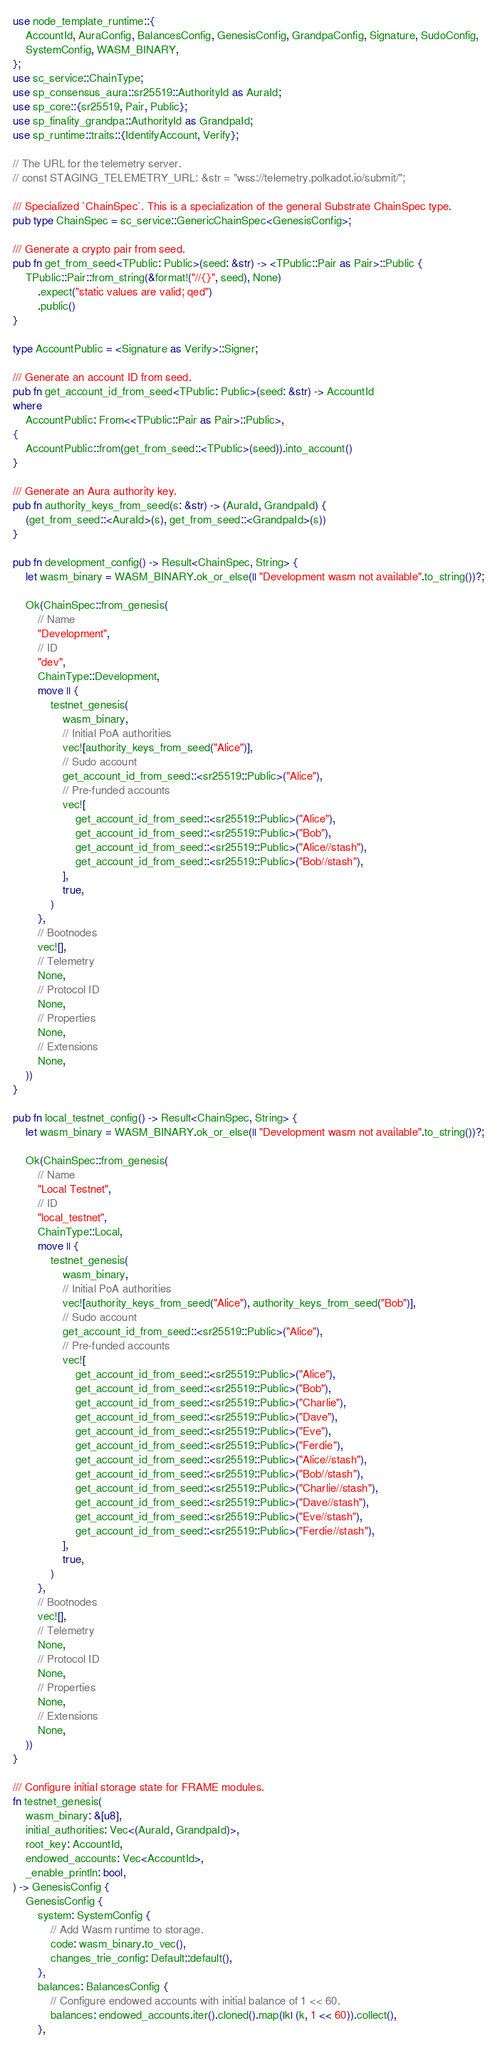<code> <loc_0><loc_0><loc_500><loc_500><_Rust_>use node_template_runtime::{
	AccountId, AuraConfig, BalancesConfig, GenesisConfig, GrandpaConfig, Signature, SudoConfig,
	SystemConfig, WASM_BINARY,
};
use sc_service::ChainType;
use sp_consensus_aura::sr25519::AuthorityId as AuraId;
use sp_core::{sr25519, Pair, Public};
use sp_finality_grandpa::AuthorityId as GrandpaId;
use sp_runtime::traits::{IdentifyAccount, Verify};

// The URL for the telemetry server.
// const STAGING_TELEMETRY_URL: &str = "wss://telemetry.polkadot.io/submit/";

/// Specialized `ChainSpec`. This is a specialization of the general Substrate ChainSpec type.
pub type ChainSpec = sc_service::GenericChainSpec<GenesisConfig>;

/// Generate a crypto pair from seed.
pub fn get_from_seed<TPublic: Public>(seed: &str) -> <TPublic::Pair as Pair>::Public {
	TPublic::Pair::from_string(&format!("//{}", seed), None)
		.expect("static values are valid; qed")
		.public()
}

type AccountPublic = <Signature as Verify>::Signer;

/// Generate an account ID from seed.
pub fn get_account_id_from_seed<TPublic: Public>(seed: &str) -> AccountId
where
	AccountPublic: From<<TPublic::Pair as Pair>::Public>,
{
	AccountPublic::from(get_from_seed::<TPublic>(seed)).into_account()
}

/// Generate an Aura authority key.
pub fn authority_keys_from_seed(s: &str) -> (AuraId, GrandpaId) {
	(get_from_seed::<AuraId>(s), get_from_seed::<GrandpaId>(s))
}

pub fn development_config() -> Result<ChainSpec, String> {
	let wasm_binary = WASM_BINARY.ok_or_else(|| "Development wasm not available".to_string())?;

	Ok(ChainSpec::from_genesis(
		// Name
		"Development",
		// ID
		"dev",
		ChainType::Development,
		move || {
			testnet_genesis(
				wasm_binary,
				// Initial PoA authorities
				vec![authority_keys_from_seed("Alice")],
				// Sudo account
				get_account_id_from_seed::<sr25519::Public>("Alice"),
				// Pre-funded accounts
				vec![
					get_account_id_from_seed::<sr25519::Public>("Alice"),
					get_account_id_from_seed::<sr25519::Public>("Bob"),
					get_account_id_from_seed::<sr25519::Public>("Alice//stash"),
					get_account_id_from_seed::<sr25519::Public>("Bob//stash"),
				],
				true,
			)
		},
		// Bootnodes
		vec![],
		// Telemetry
		None,
		// Protocol ID
		None,
		// Properties
		None,
		// Extensions
		None,
	))
}

pub fn local_testnet_config() -> Result<ChainSpec, String> {
	let wasm_binary = WASM_BINARY.ok_or_else(|| "Development wasm not available".to_string())?;

	Ok(ChainSpec::from_genesis(
		// Name
		"Local Testnet",
		// ID
		"local_testnet",
		ChainType::Local,
		move || {
			testnet_genesis(
				wasm_binary,
				// Initial PoA authorities
				vec![authority_keys_from_seed("Alice"), authority_keys_from_seed("Bob")],
				// Sudo account
				get_account_id_from_seed::<sr25519::Public>("Alice"),
				// Pre-funded accounts
				vec![
					get_account_id_from_seed::<sr25519::Public>("Alice"),
					get_account_id_from_seed::<sr25519::Public>("Bob"),
					get_account_id_from_seed::<sr25519::Public>("Charlie"),
					get_account_id_from_seed::<sr25519::Public>("Dave"),
					get_account_id_from_seed::<sr25519::Public>("Eve"),
					get_account_id_from_seed::<sr25519::Public>("Ferdie"),
					get_account_id_from_seed::<sr25519::Public>("Alice//stash"),
					get_account_id_from_seed::<sr25519::Public>("Bob//stash"),
					get_account_id_from_seed::<sr25519::Public>("Charlie//stash"),
					get_account_id_from_seed::<sr25519::Public>("Dave//stash"),
					get_account_id_from_seed::<sr25519::Public>("Eve//stash"),
					get_account_id_from_seed::<sr25519::Public>("Ferdie//stash"),
				],
				true,
			)
		},
		// Bootnodes
		vec![],
		// Telemetry
		None,
		// Protocol ID
		None,
		// Properties
		None,
		// Extensions
		None,
	))
}

/// Configure initial storage state for FRAME modules.
fn testnet_genesis(
	wasm_binary: &[u8],
	initial_authorities: Vec<(AuraId, GrandpaId)>,
	root_key: AccountId,
	endowed_accounts: Vec<AccountId>,
	_enable_println: bool,
) -> GenesisConfig {
	GenesisConfig {
		system: SystemConfig {
			// Add Wasm runtime to storage.
			code: wasm_binary.to_vec(),
			changes_trie_config: Default::default(),
		},
		balances: BalancesConfig {
			// Configure endowed accounts with initial balance of 1 << 60.
			balances: endowed_accounts.iter().cloned().map(|k| (k, 1 << 60)).collect(),
		},</code> 